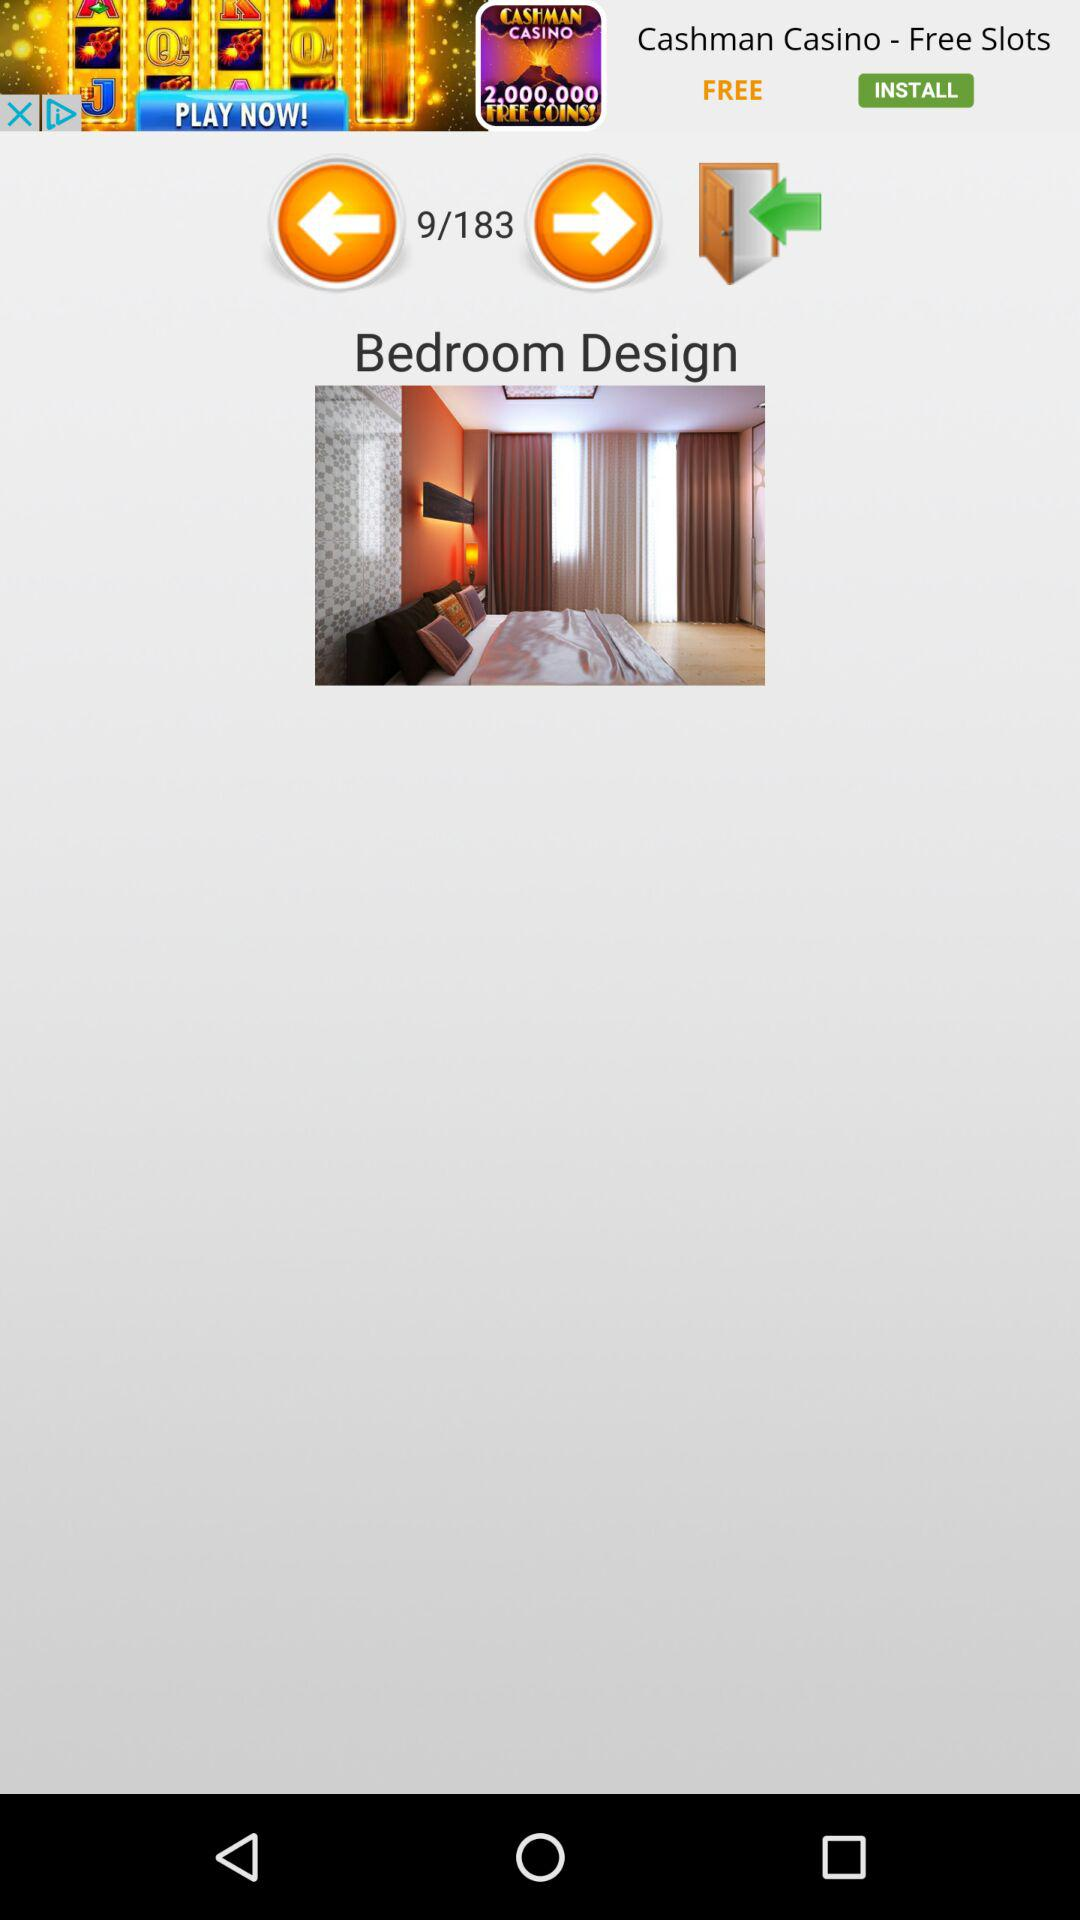How many design images are there? There are 183 design images. 